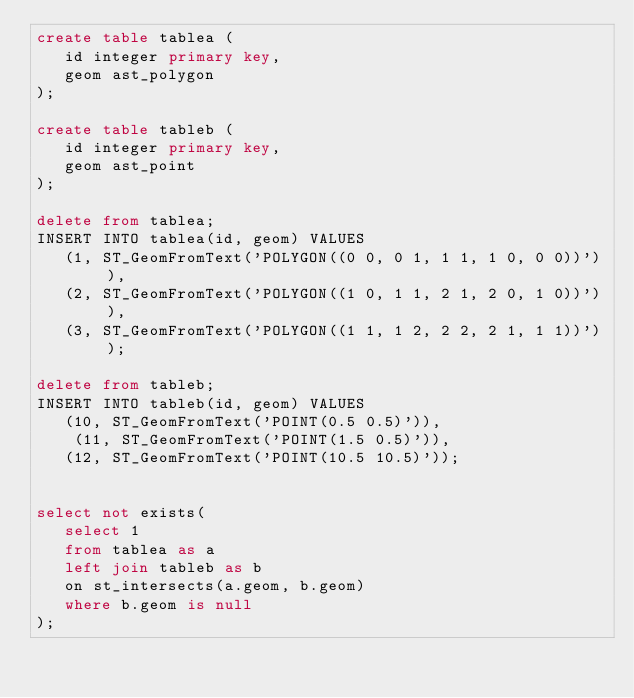<code> <loc_0><loc_0><loc_500><loc_500><_SQL_>create table tablea (
   id integer primary key,
   geom ast_polygon
);

create table tableb (
   id integer primary key,
   geom ast_point
);

delete from tablea;
INSERT INTO tablea(id, geom) VALUES
   (1, ST_GeomFromText('POLYGON((0 0, 0 1, 1 1, 1 0, 0 0))') ),
   (2, ST_GeomFromText('POLYGON((1 0, 1 1, 2 1, 2 0, 1 0))') ),
   (3, ST_GeomFromText('POLYGON((1 1, 1 2, 2 2, 2 1, 1 1))') );

delete from tableb;
INSERT INTO tableb(id, geom) VALUES
   (10, ST_GeomFromText('POINT(0.5 0.5)')),
	(11, ST_GeomFromText('POINT(1.5 0.5)')),
   (12, ST_GeomFromText('POINT(10.5 10.5)'));


select not exists(
   select 1
   from tablea as a
   left join tableb as b
   on st_intersects(a.geom, b.geom)
   where b.geom is null
);
</code> 